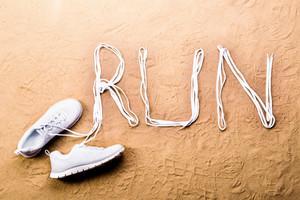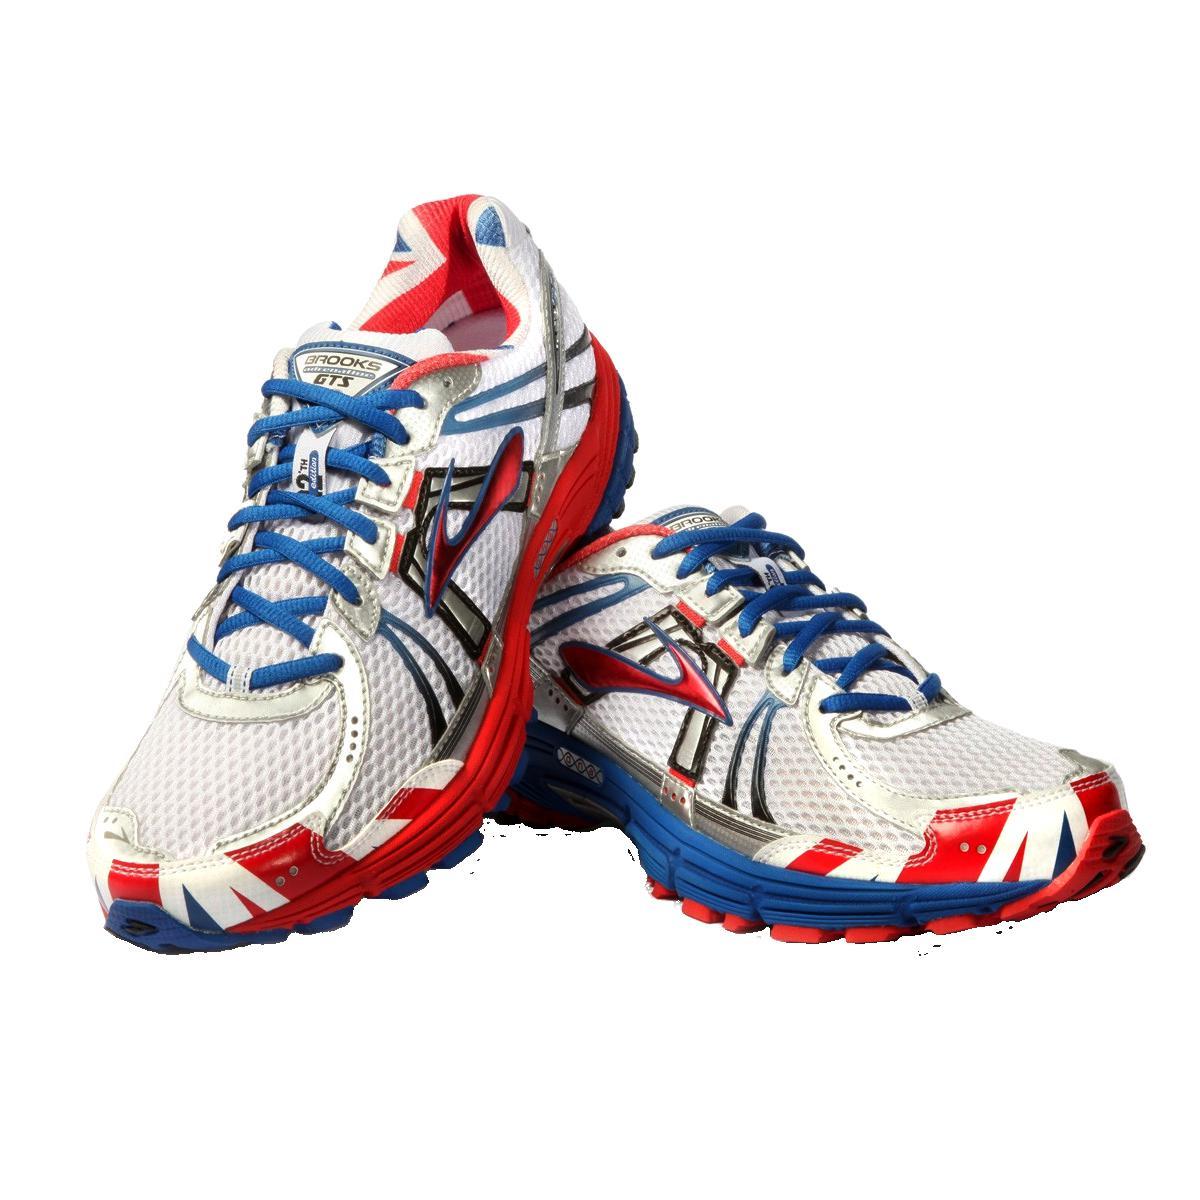The first image is the image on the left, the second image is the image on the right. Analyze the images presented: Is the assertion "One of the images shows a black shoe near a bottle of water." valid? Answer yes or no. No. The first image is the image on the left, the second image is the image on the right. Assess this claim about the two images: "There is a pair of empty shoes in the right image.". Correct or not? Answer yes or no. Yes. 